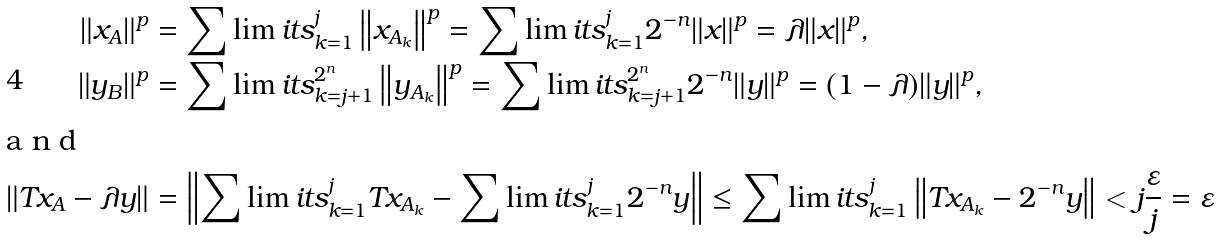Convert formula to latex. <formula><loc_0><loc_0><loc_500><loc_500>\left \| x _ { A } \right \| ^ { p } & = \sum \lim i t s _ { k = 1 } ^ { j } \left \| x _ { A _ { k } } \right \| ^ { p } = \sum \lim i t s _ { k = 1 } ^ { j } 2 ^ { - n } \| x \| ^ { p } = \lambda \| x \| ^ { p } , \\ \left \| y _ { B } \right \| ^ { p } & = \sum \lim i t s _ { k = j + 1 } ^ { 2 ^ { n } } \left \| y _ { A _ { k } } \right \| ^ { p } = \sum \lim i t s _ { k = j + 1 } ^ { 2 ^ { n } } 2 ^ { - n } \| y \| ^ { p } = ( 1 - \lambda ) \| y \| ^ { p } , \\ \intertext { a n d } \left \| T x _ { A } - \lambda y \right \| & = \left \| \sum \lim i t s _ { k = 1 } ^ { j } T x _ { A _ { k } } - \sum \lim i t s _ { k = 1 } ^ { j } 2 ^ { - n } y \right \| \leq \sum \lim i t s _ { k = 1 } ^ { j } \left \| T x _ { A _ { k } } - 2 ^ { - n } y \right \| < j \frac { \varepsilon } { j } = \varepsilon</formula> 